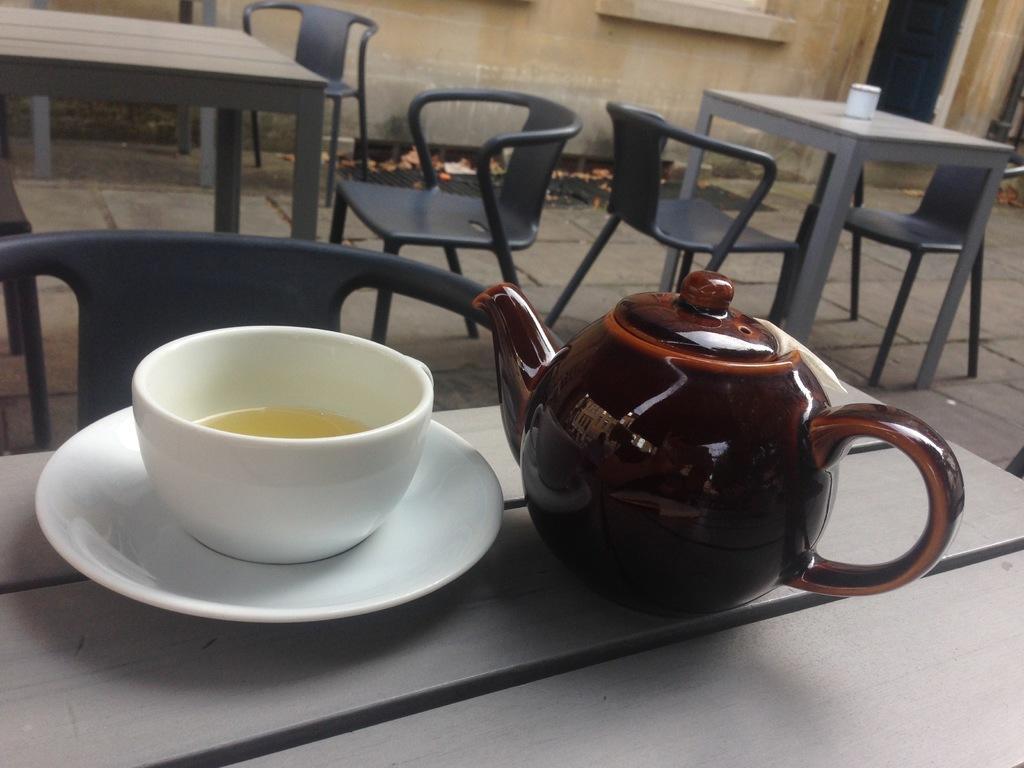How would you summarize this image in a sentence or two? On the bottom of the image there is a table. On the table one cup and one saucer and one teapot are there. In the background also there are two tables and some chairs. On the top right of the image there is a wall. 